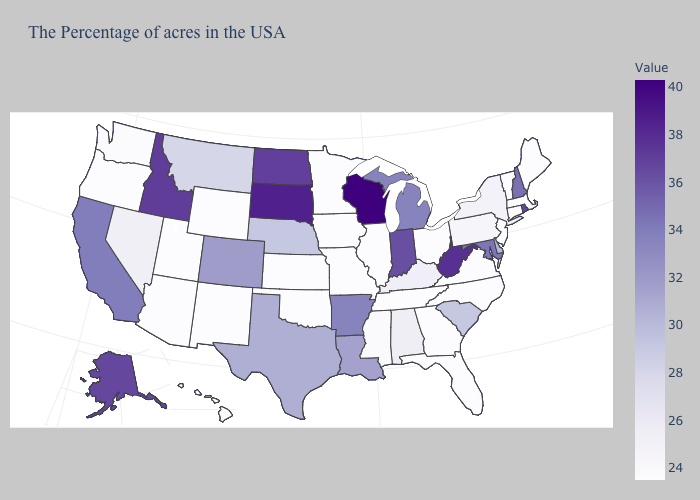Which states hav the highest value in the Northeast?
Quick response, please. Rhode Island. Among the states that border Missouri , does Tennessee have the lowest value?
Short answer required. Yes. Among the states that border Massachusetts , which have the lowest value?
Quick response, please. Vermont, Connecticut. Does Utah have the lowest value in the USA?
Concise answer only. Yes. Does New Hampshire have the lowest value in the Northeast?
Concise answer only. No. 